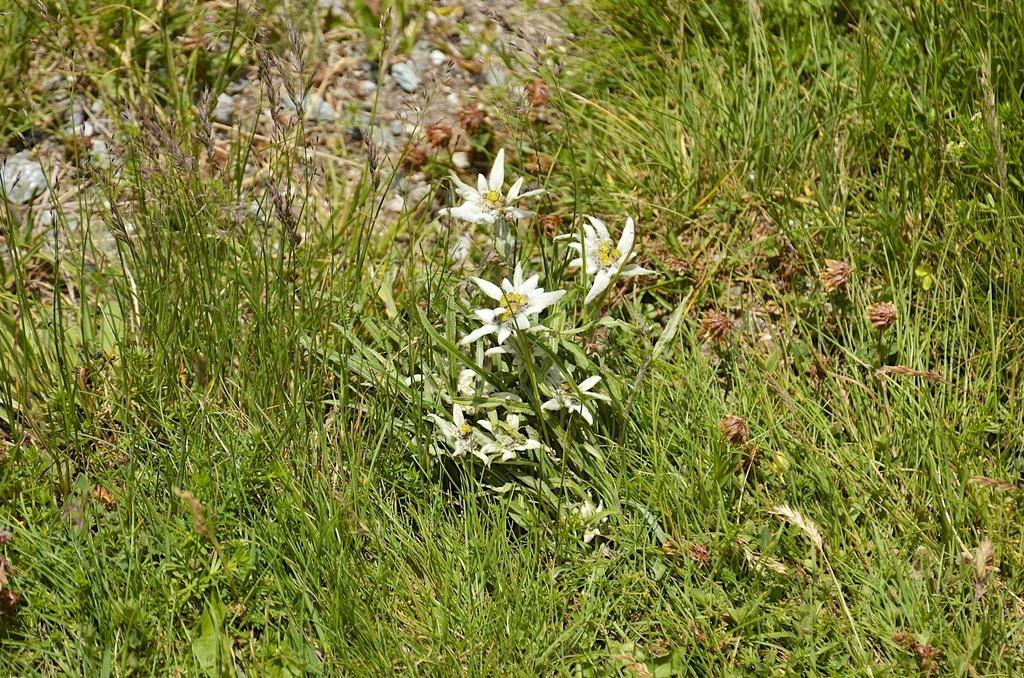What type of flowers are on the ground in the image? There are white color flowers on the ground. What else can be seen on the ground in the image? There is grass on the ground. What type of cord is hanging from the window in the image? There is no window or cord present in the image; it only features white color flowers and grass on the ground. 